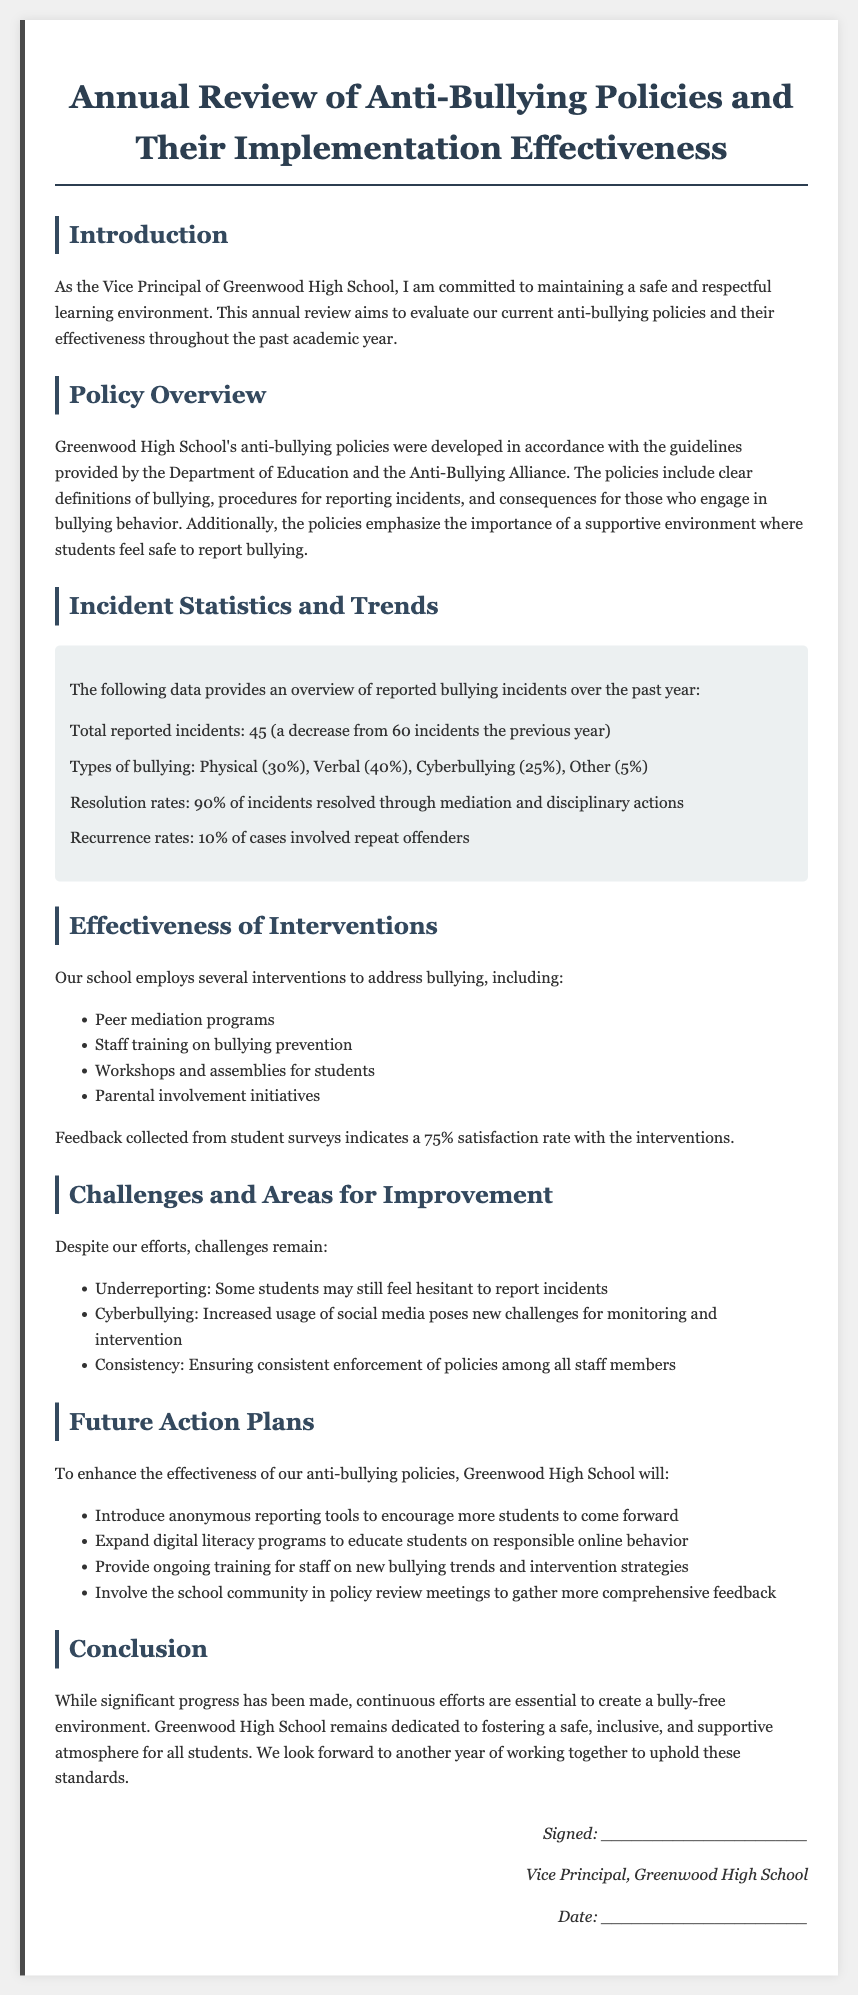What is the total reported incidents of bullying? The total reported incidents of bullying are explicitly stated in the document, showing a figure of 45.
Answer: 45 What was the satisfaction rate from student surveys? The document mentions that feedback from student surveys indicates a satisfaction rate of 75%.
Answer: 75% What type of intervention addresses 'Cyberbullying'? The document lists expanding digital literacy programs as part of the future action plans to address Cyberbullying.
Answer: Digital literacy programs What percentage of incidents were resolved? According to the statistics section, 90% of reported incidents were resolved.
Answer: 90% What is a challenge mentioned in maintaining the anti-bullying policy? The document highlights underreporting as a significant challenge in the effectiveness of the anti-bullying policy.
Answer: Underreporting What organization’s guidelines are mentioned for developing policies? The guidelines for developing the policies are from the Department of Education and the Anti-Bullying Alliance.
Answer: Department of Education and Anti-Bullying Alliance What will the school introduce to encourage reporting of bullying? The document states that anonymous reporting tools will be introduced to encourage more students to come forward.
Answer: Anonymous reporting tools How many types of bullying are listed, and what are they? The document lists four types of bullying, which are Physical, Verbal, Cyberbullying, and Other.
Answer: Physical, Verbal, Cyberbullying, Other 